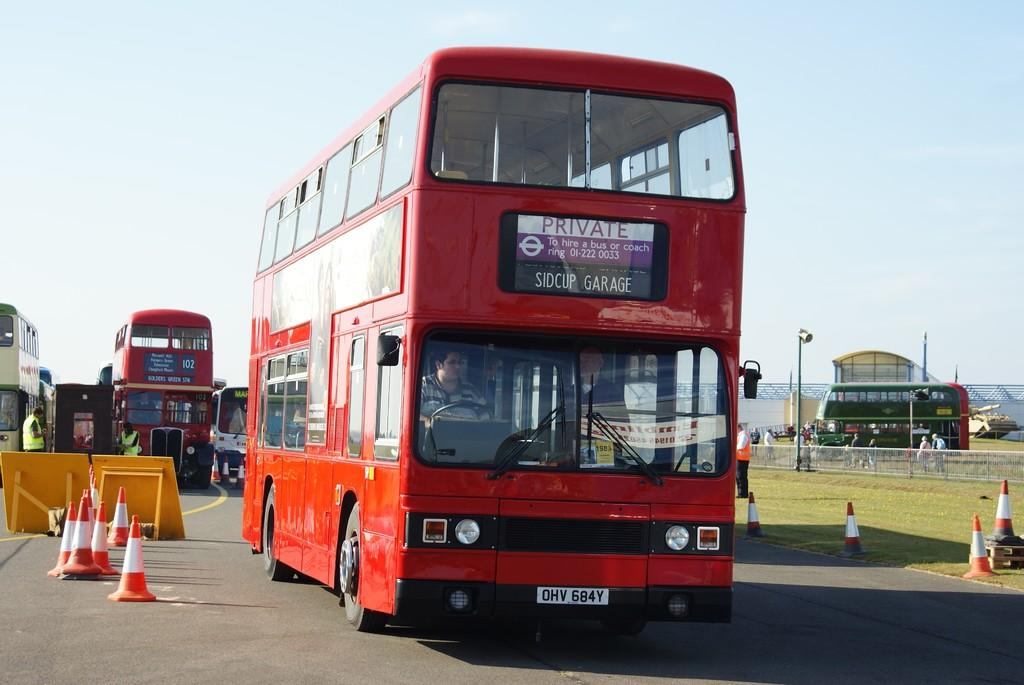What can be seen on the road in the image? There are vehicles on the road in the image. What objects are present to guide or control traffic in the image? There are traffic cones in the image. Who or what is present in the image besides vehicles and traffic cones? There are people in the image. What structures can be seen in the background of the image? There is a shed, poles, and a wall in the background of the image. What part of the natural environment is visible in the image? The sky is visible in the background of the image. What type of pets can be seen grooming themselves in the image? There are no pets present in the image. What is the date on the calendar in the image? There is no calendar present in the image. 